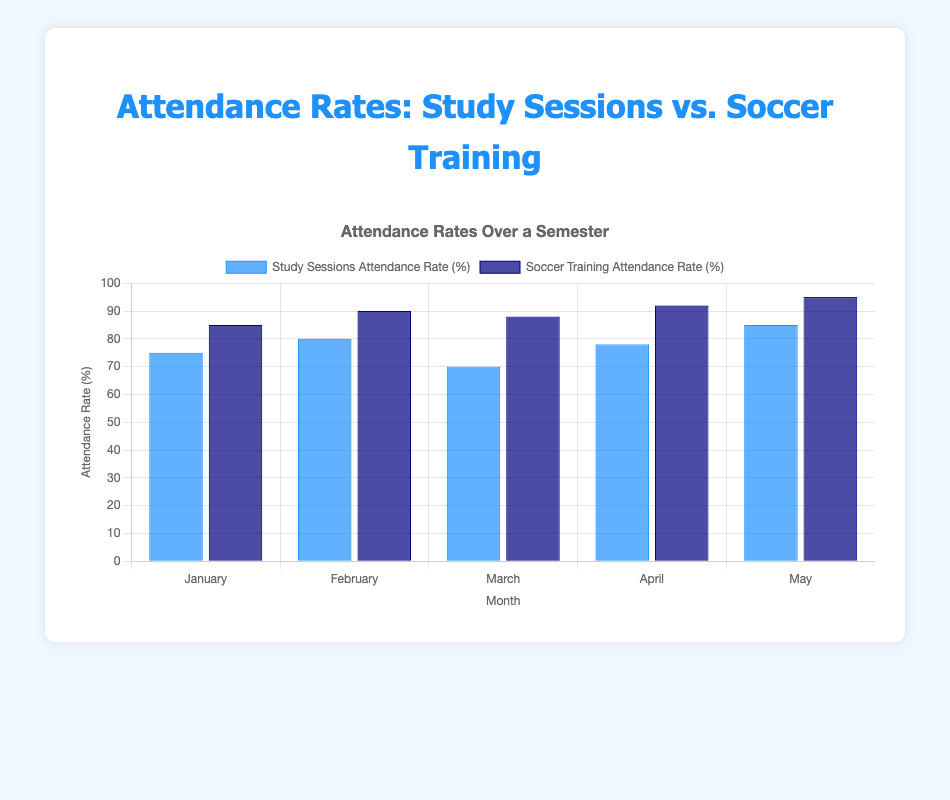Which month has the highest attendance rate for study sessions? The month with the highest attendance rate can be found by comparing the percentages for study sessions across all months. May has the highest rate at 85%.
Answer: May Which month has a greater difference between study sessions and soccer training attendance rates? To determine the month with the greatest difference, calculate the absolute difference for each month: January (10%), February (10%), March (18%), April (14%), May (10%). March has the greatest difference of 18%.
Answer: March What is the average attendance rate for soccer training over the semester? Sum the soccer training attendance rates for all months: 85 + 90 + 88 + 92 + 95 = 450. Then, divide by the number of months (5): 450 / 5 = 90%.
Answer: 90% What is the combined attendance rate for both study sessions and soccer training in April? Add the attendance rates for study sessions and soccer training in April: 78 + 92 = 170%.
Answer: 170% In which month is the difference between attendance rates for study sessions and soccer training smallest? Calculate the absolute differences: January (10%), February (10%), March (18%), April (14%), May (10%). January, February, and May all have the smallest difference of 10%.
Answer: January, February, May How does the average attendance rate for study sessions compare to that for soccer training? Calculate the average for study sessions: (75 + 80 + 70 + 78 + 85) / 5 = 77.6%. For soccer training: (85 + 90 + 88 + 92 + 95) / 5 = 90%. Compare: The average rate for study sessions is lower.
Answer: Study sessions: 77.6%, Soccer training: 90% Which bar color represents the soccer training attendance rates? Observe the colors in the chart and identify that soccer training attendance rates are represented by the dark blue bars.
Answer: Dark blue 